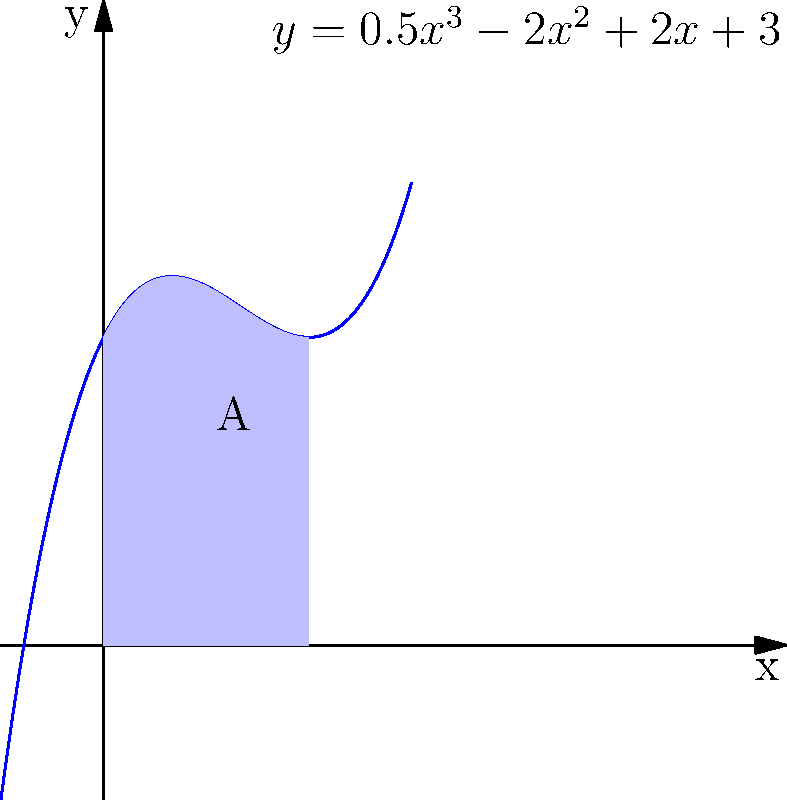Dado o polinômio $f(x) = 0.5x^3 - 2x^2 + 2x + 3$, que representa a volatilidade de um ativo cripto ao longo do tempo, calcule a área A sob a curva entre $x=0$ e $x=2$. Como essa área pode ser interpretada no contexto de análise de volatilidade de ativos cripto? Para calcular a área sob a curva, seguimos estes passos:

1) A área é dada pela integral definida de $f(x)$ de 0 a 2:

   $A = \int_0^2 (0.5x^3 - 2x^2 + 2x + 3) dx$

2) Integramos termo a termo:

   $A = [\frac{0.5x^4}{4} - \frac{2x^3}{3} + x^2 + 3x]_0^2$

3) Calculamos os valores nos limites:

   $A = (\frac{0.5(2^4)}{4} - \frac{2(2^3)}{3} + 2^2 + 3(2)) - (\frac{0.5(0^4)}{4} - \frac{2(0^3)}{3} + 0^2 + 3(0))$

4) Simplificamos:

   $A = (4 - \frac{16}{3} + 4 + 6) - 0 = 14 - \frac{16}{3} = \frac{26}{3} \approx 8.67$

Interpretação: A área sob a curva representa a volatilidade acumulada do ativo cripto no período de tempo de 0 a 2. Um valor maior indica maior volatilidade total nesse intervalo, o que pode ser usado para comparar diferentes períodos ou ativos em termos de estabilidade de preço.
Answer: $\frac{26}{3}$ unidades quadradas; representa volatilidade acumulada. 